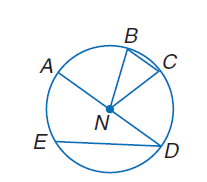Answer the mathemtical geometry problem and directly provide the correct option letter.
Question: If B E \cong E D and m \widehat E D = 120, find m \widehat B E.
Choices: A: 120 B: 135 C: 160 D: 175 A 